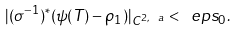<formula> <loc_0><loc_0><loc_500><loc_500>| ( \sigma ^ { - 1 } ) ^ { \ast } ( \psi ( T ) - \rho _ { 1 } ) | _ { C ^ { 2 , \ a } } < \ e p s _ { 0 } .</formula> 